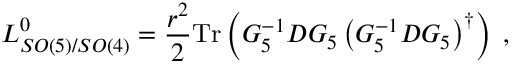Convert formula to latex. <formula><loc_0><loc_0><loc_500><loc_500>L _ { S O ( 5 ) / S O ( 4 ) } ^ { 0 } = \frac { { r } ^ { 2 } } { 2 } T r \left ( G _ { 5 } ^ { - 1 } D G _ { 5 } \left ( G _ { 5 } ^ { - 1 } D G _ { 5 } \right ) ^ { \dag } \right ) \, ,</formula> 